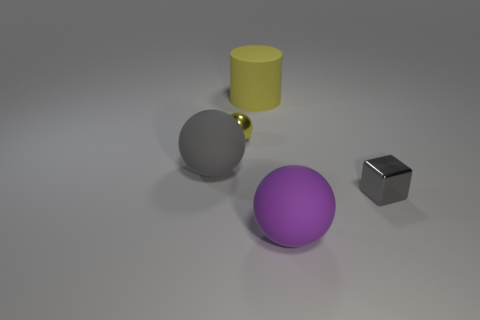What shape is the small shiny thing that is in front of the large gray matte object behind the large purple matte sphere? The small shiny object situated in front of the large gray matte cylinder and behind the large purple matte sphere is a sphere itself, reflecting the light and exhibiting a glossy finish. 